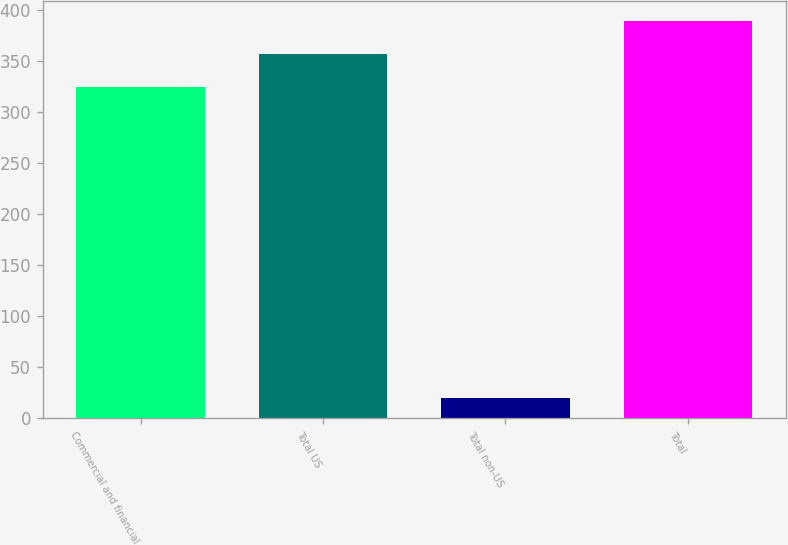Convert chart to OTSL. <chart><loc_0><loc_0><loc_500><loc_500><bar_chart><fcel>Commercial and financial<fcel>Total US<fcel>Total non-US<fcel>Total<nl><fcel>324<fcel>356.4<fcel>20<fcel>388.8<nl></chart> 